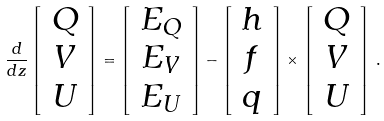<formula> <loc_0><loc_0><loc_500><loc_500>\frac { d } { d z } \left [ \begin{array} { c } Q \\ V \\ U \end{array} \right ] = \left [ \begin{array} { c } E _ { Q } \\ E _ { V } \\ E _ { U } \end{array} \right ] - \left [ \begin{array} { c } h \\ f \\ q \end{array} \right ] \times \left [ \begin{array} { c } Q \\ V \\ U \end{array} \right ] \, .</formula> 